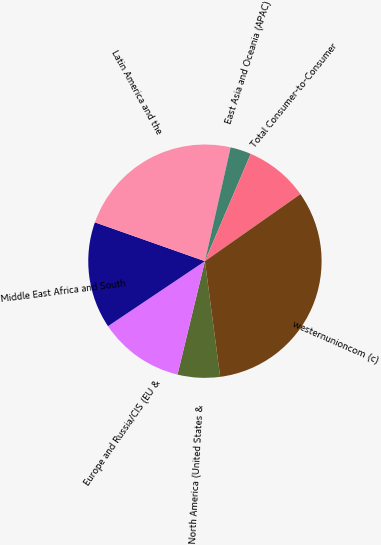<chart> <loc_0><loc_0><loc_500><loc_500><pie_chart><fcel>North America (United States &<fcel>Europe and Russia/CIS (EU &<fcel>Middle East Africa and South<fcel>Latin America and the<fcel>East Asia and Oceania (APAC)<fcel>Total Consumer-to-Consumer<fcel>westernunioncom (c)<nl><fcel>5.86%<fcel>11.82%<fcel>14.8%<fcel>23.13%<fcel>2.88%<fcel>8.84%<fcel>32.65%<nl></chart> 